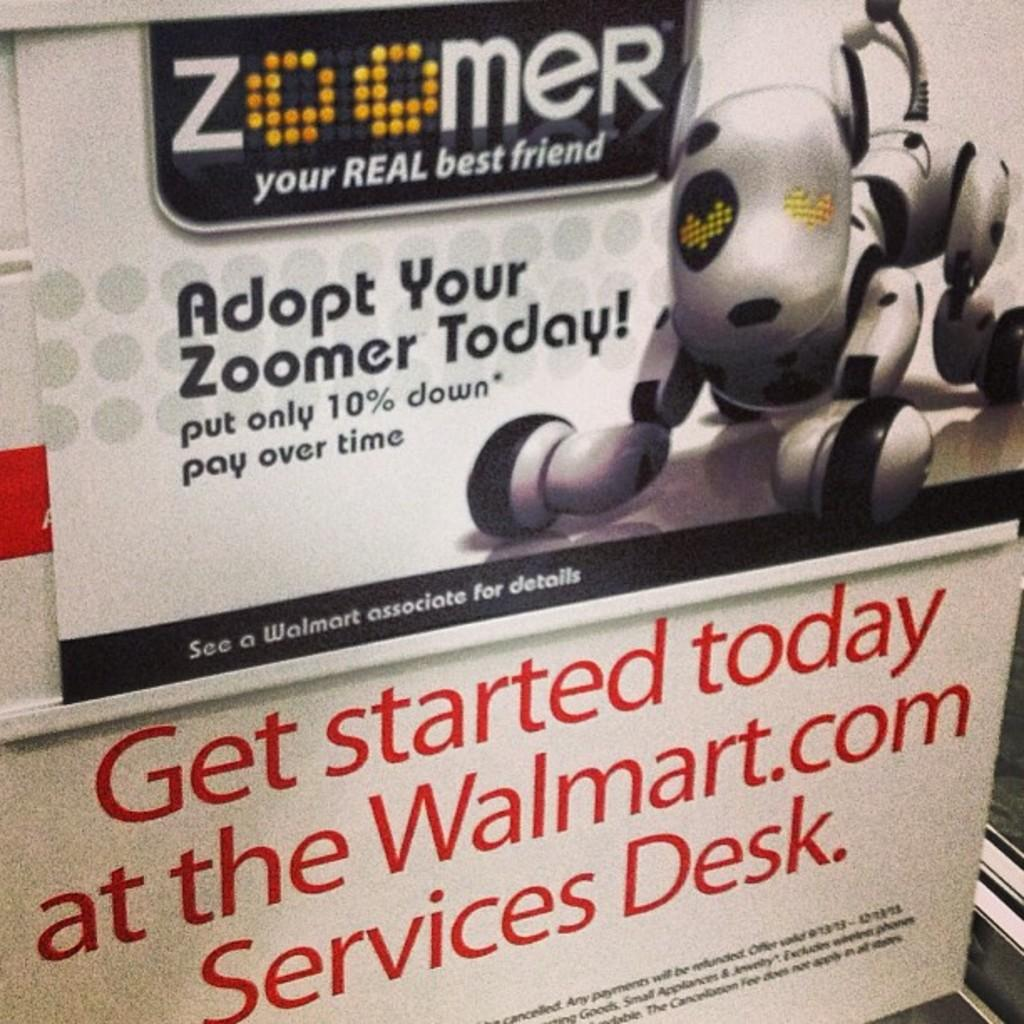Provide a one-sentence caption for the provided image. An advertisement for a robotic dog displayed in the store of Walmart. 